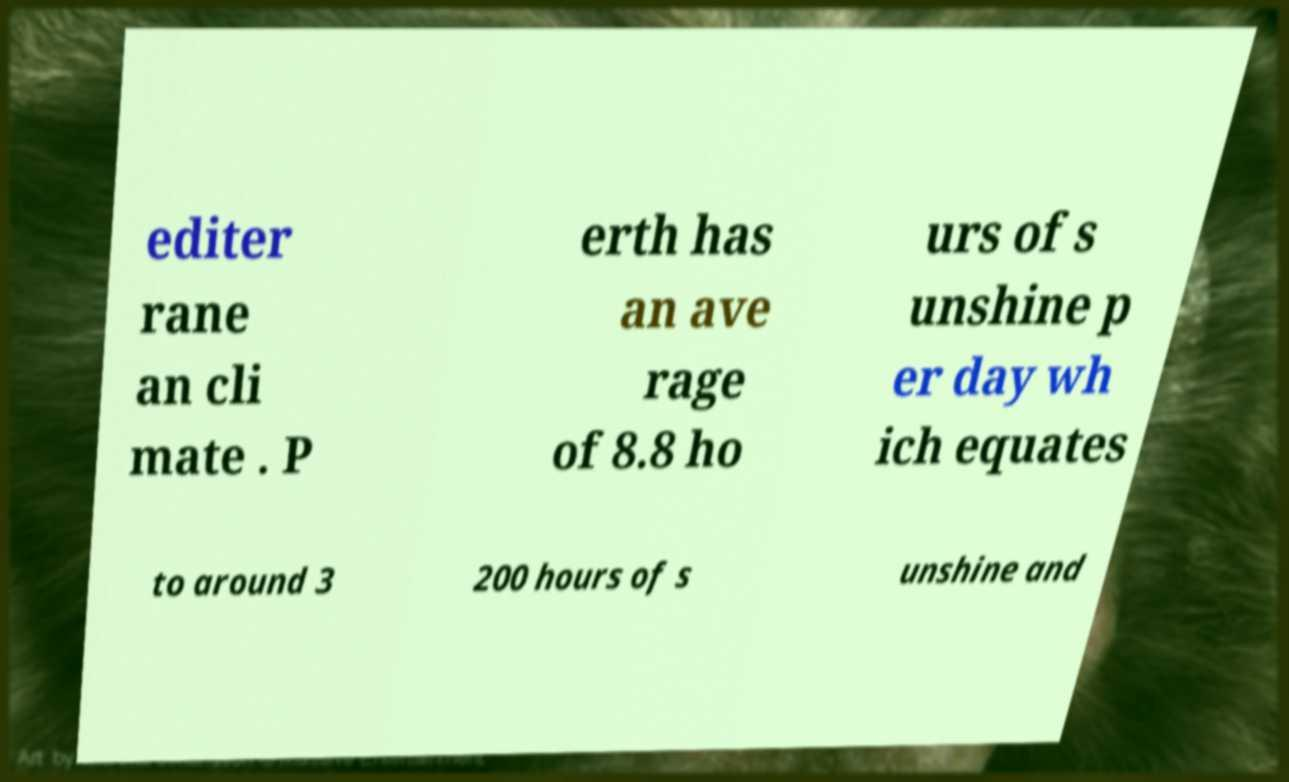I need the written content from this picture converted into text. Can you do that? editer rane an cli mate . P erth has an ave rage of 8.8 ho urs of s unshine p er day wh ich equates to around 3 200 hours of s unshine and 